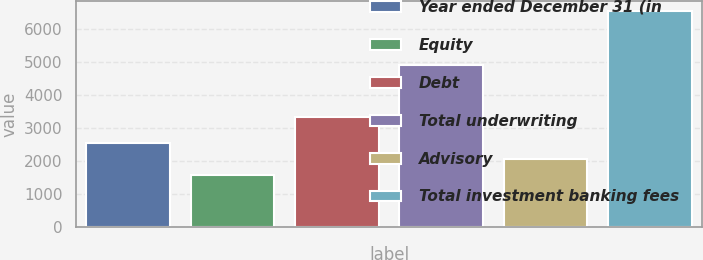<chart> <loc_0><loc_0><loc_500><loc_500><bar_chart><fcel>Year ended December 31 (in<fcel>Equity<fcel>Debt<fcel>Total underwriting<fcel>Advisory<fcel>Total investment banking fees<nl><fcel>2565.2<fcel>1571<fcel>3340<fcel>4911<fcel>2068.1<fcel>6542<nl></chart> 